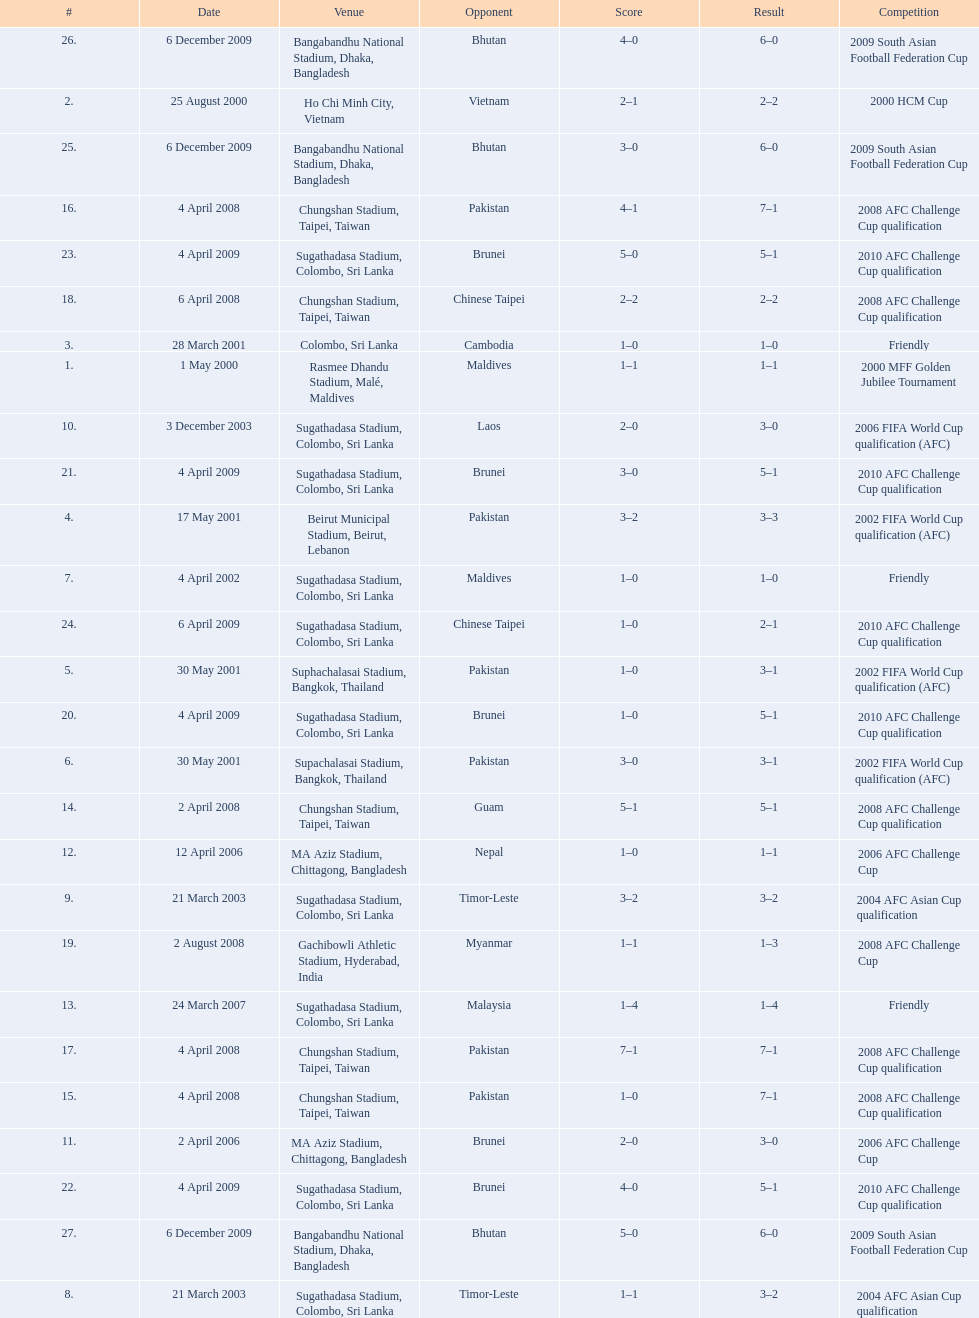What venues are listed? Rasmee Dhandu Stadium, Malé, Maldives, Ho Chi Minh City, Vietnam, Colombo, Sri Lanka, Beirut Municipal Stadium, Beirut, Lebanon, Suphachalasai Stadium, Bangkok, Thailand, MA Aziz Stadium, Chittagong, Bangladesh, Sugathadasa Stadium, Colombo, Sri Lanka, Chungshan Stadium, Taipei, Taiwan, Gachibowli Athletic Stadium, Hyderabad, India, Sugathadasa Stadium, Colombo, Sri Lanka, Bangabandhu National Stadium, Dhaka, Bangladesh. Which is top listed? Rasmee Dhandu Stadium, Malé, Maldives. 